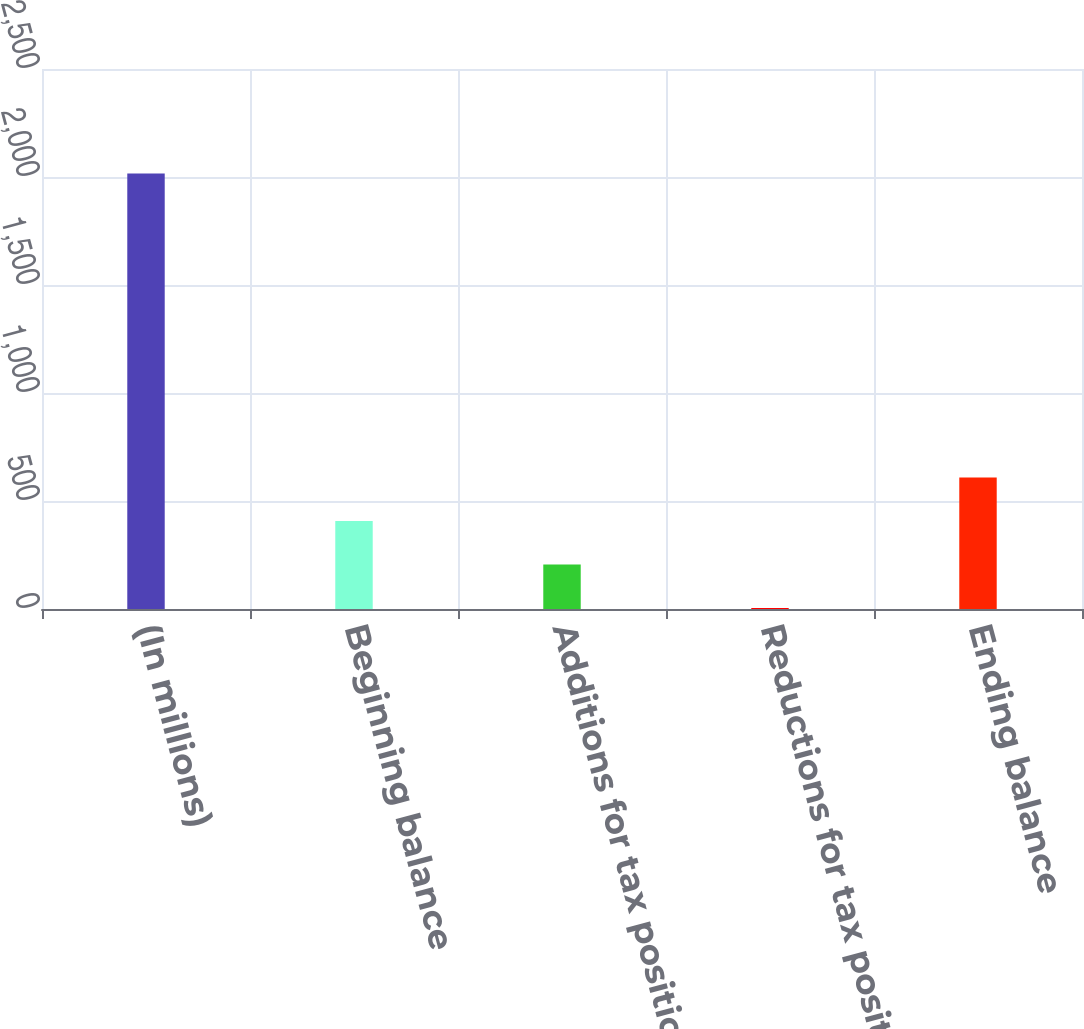Convert chart to OTSL. <chart><loc_0><loc_0><loc_500><loc_500><bar_chart><fcel>(In millions)<fcel>Beginning balance<fcel>Additions for tax positions of<fcel>Reductions for tax positions<fcel>Ending balance<nl><fcel>2016<fcel>407.2<fcel>206.1<fcel>5<fcel>608.3<nl></chart> 